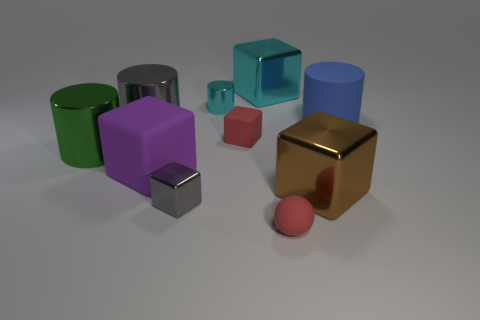Is the color of the tiny matte cube the same as the tiny matte ball? yes 